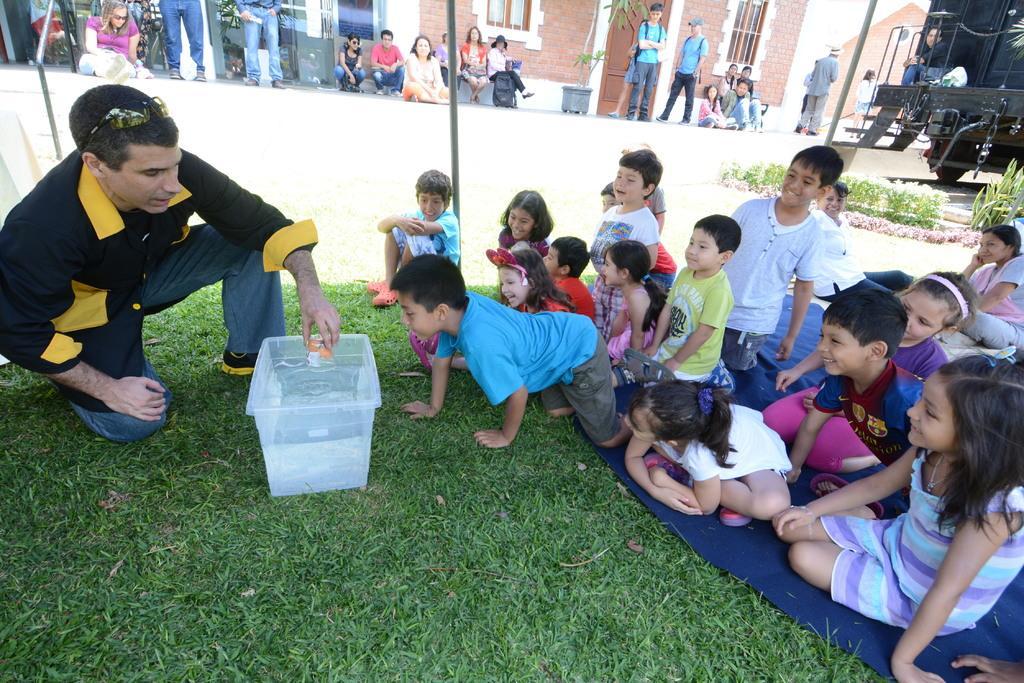Can you describe this image briefly? In this picture there are group of persons sitting, standing and kneeling. There is grass on the ground and there is a white colour container in the center. In the background there are buildings, there is a door and there are windows. On the right side there is a vehicle and there is a plant. 